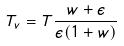<formula> <loc_0><loc_0><loc_500><loc_500>T _ { v } = T \frac { w + \epsilon } { \epsilon ( 1 + w ) }</formula> 